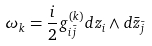<formula> <loc_0><loc_0><loc_500><loc_500>\omega _ { k } = \frac { i } { 2 } g ^ { ( k ) } _ { i \bar { j } } d z _ { i } \wedge d \bar { z } _ { \bar { j } }</formula> 